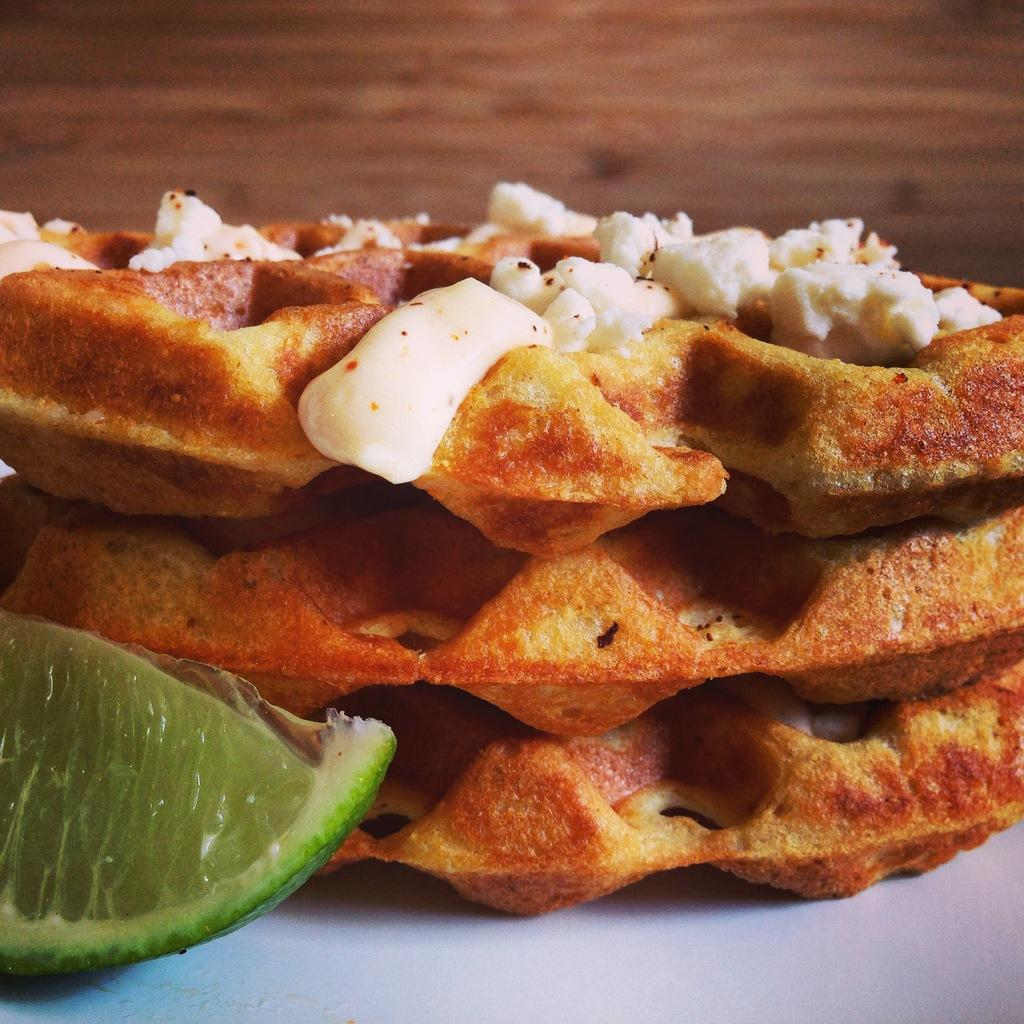What type of items are present in the image? There are food items in the image. Can you describe the surface on which the food items are placed? The food items are on a white surface. Where is the cart located in the image? There is no cart present in the image. What type of grass can be seen growing near the food items in the image? There is no grass present in the image. 